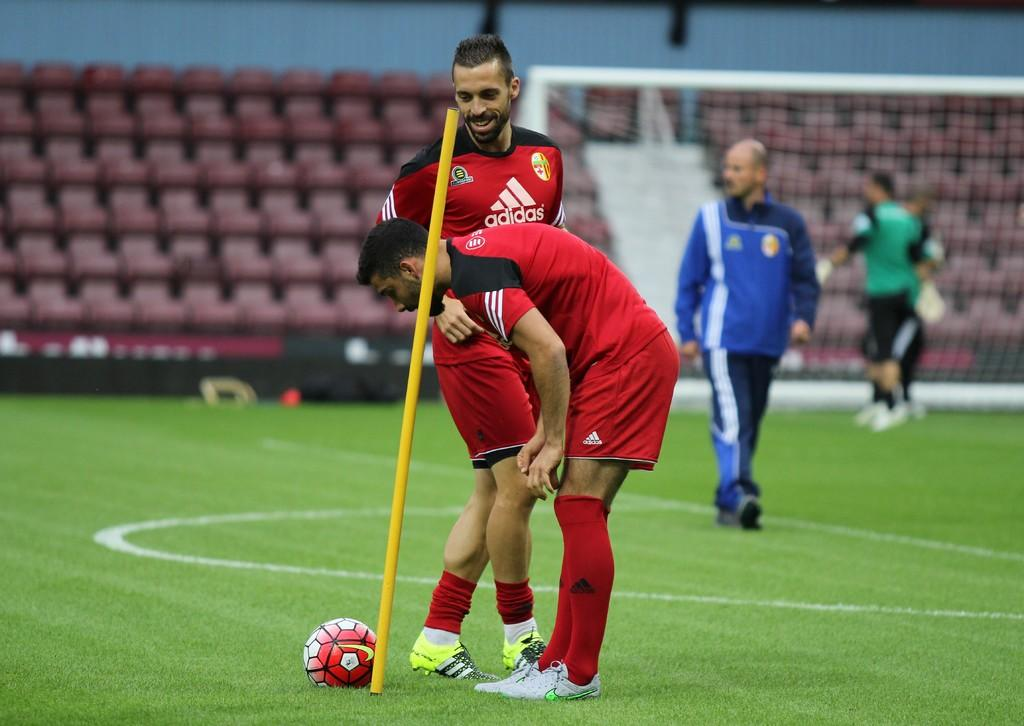<image>
Share a concise interpretation of the image provided. soccer players with one wearing a jersey that says 'adidas' on it 